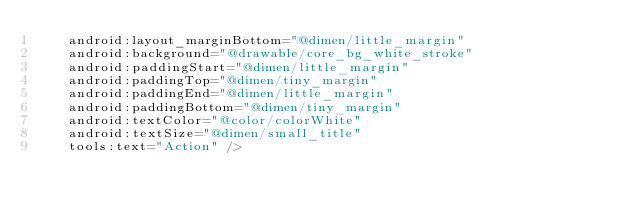Convert code to text. <code><loc_0><loc_0><loc_500><loc_500><_XML_>    android:layout_marginBottom="@dimen/little_margin"
    android:background="@drawable/core_bg_white_stroke"
    android:paddingStart="@dimen/little_margin"
    android:paddingTop="@dimen/tiny_margin"
    android:paddingEnd="@dimen/little_margin"
    android:paddingBottom="@dimen/tiny_margin"
    android:textColor="@color/colorWhite"
    android:textSize="@dimen/small_title"
    tools:text="Action" /></code> 